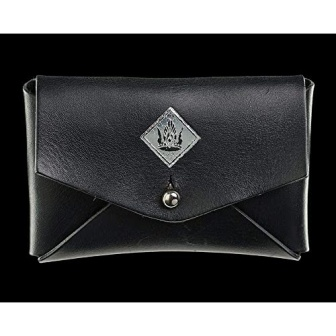What might the emblem on the wallet signify? The emblem on the wallet, featuring a crown and wings within a diamond shape, is likely symbolic. The crown generally represents power, authority, or a royal quality, while wings can imply freedom, protection, or swiftness. Together, they might suggest a brand identity that values empowerment and elegance, or they could signify a special edition line. Emblems like this often serve as distinctive markers of designer goods, emphasizing their exclusivity and luxury status. 